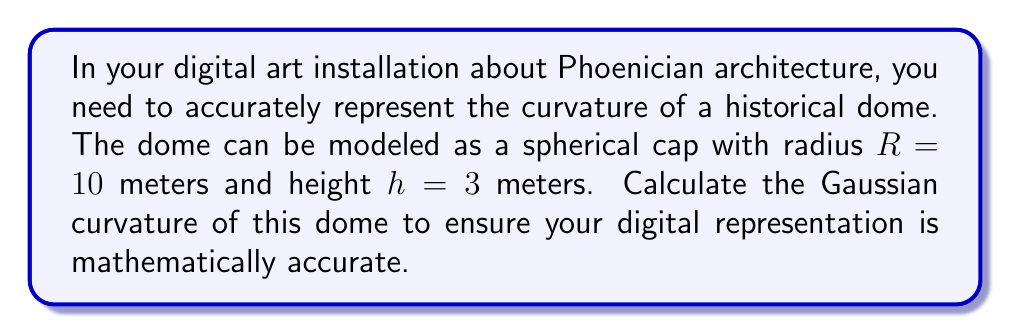Show me your answer to this math problem. To calculate the Gaussian curvature of a spherical dome, we'll follow these steps:

1. Recall that for a sphere, the Gaussian curvature $K$ is constant and given by:

   $$K = \frac{1}{R^2}$$

   where $R$ is the radius of the sphere.

2. However, we're given the height $h$ of the spherical cap, not the full radius. We need to find $R$ using the height and the chord length.

3. Let's visualize the dome:

   [asy]
   import geometry;
   
   size(200);
   pair O = (0,0);
   pair A = (-8,0);
   pair B = (8,0);
   pair C = (0,6);
   
   draw(Circle(O,10));
   draw(A--B);
   draw(O--C);
   
   label("R", (5,5), NE);
   label("h", (0,3), E);
   label("r", (4,0), S);
   
   dot("O", O, S);
   dot("A", A, SW);
   dot("B", B, SE);
   dot("C", C, N);
   [/asy]

4. In this diagram, $OC = R$, $AC = r$ (half-chord length), and $OA = \sqrt{R^2 - r^2}$.

5. We can write: $R - h = \sqrt{R^2 - r^2}$

6. Squaring both sides:
   $$(R - h)^2 = R^2 - r^2$$

7. Expanding:
   $$R^2 - 2Rh + h^2 = R^2 - r^2$$

8. Simplifying:
   $$r^2 = 2Rh - h^2$$

9. We're given that $h = 3$ and $R = 10$. Let's substitute:
   $$r^2 = 2(10)(3) - 3^2 = 60 - 9 = 51$$

10. Now we can calculate the Gaussian curvature:
    $$K = \frac{1}{R^2} = \frac{1}{10^2} = \frac{1}{100} = 0.01 \text{ m}^{-2}$$
Answer: $0.01 \text{ m}^{-2}$ 